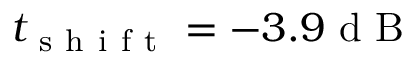<formula> <loc_0><loc_0><loc_500><loc_500>t _ { s h i f t } = - 3 . 9 d B</formula> 